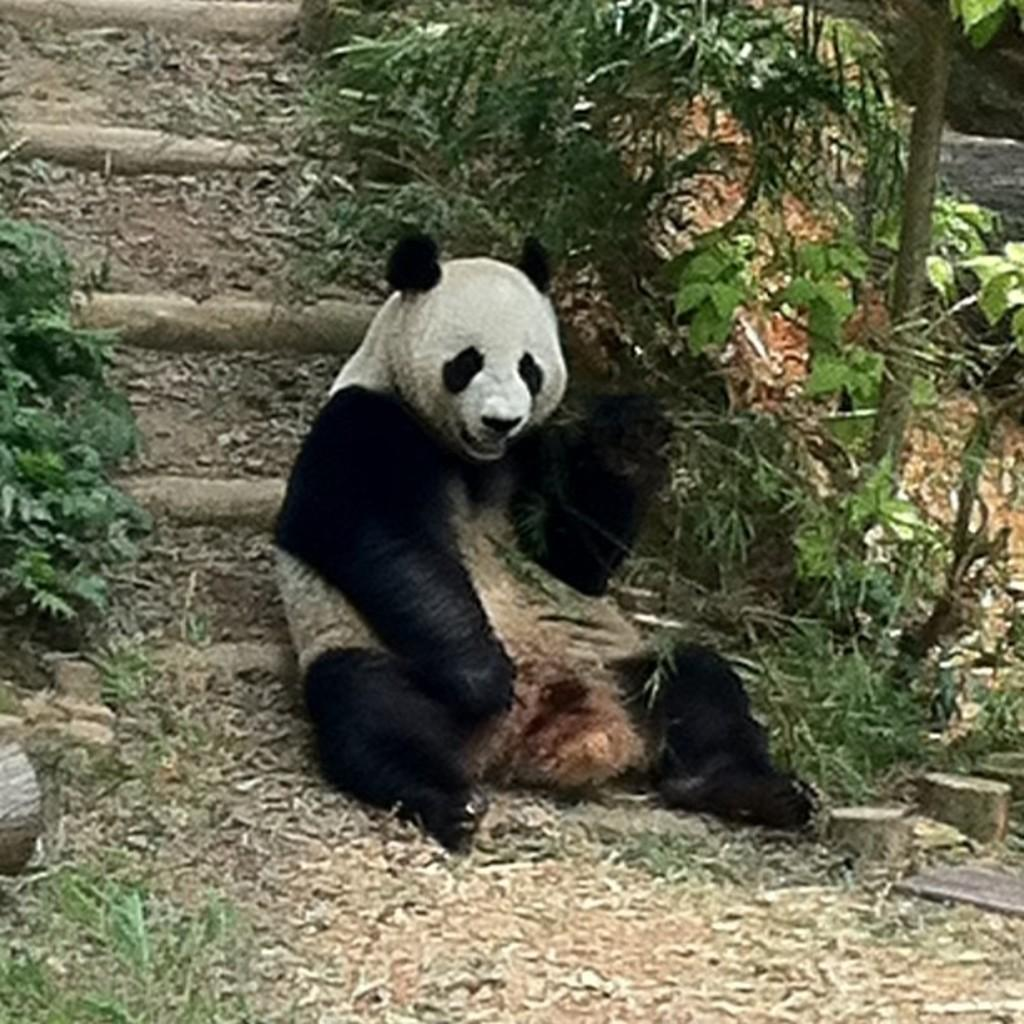What type of animal can be seen in the image? There is an animal sitting on the land in the image. What architectural feature is visible in the background of the image? There are stairs visible in the background of the image. What type of vegetation is present in the background of the image? There are plants in the background of the image. What question is the animal asking in the image? There is no indication in the image that the animal is asking a question, as animals do not have the ability to ask questions. 